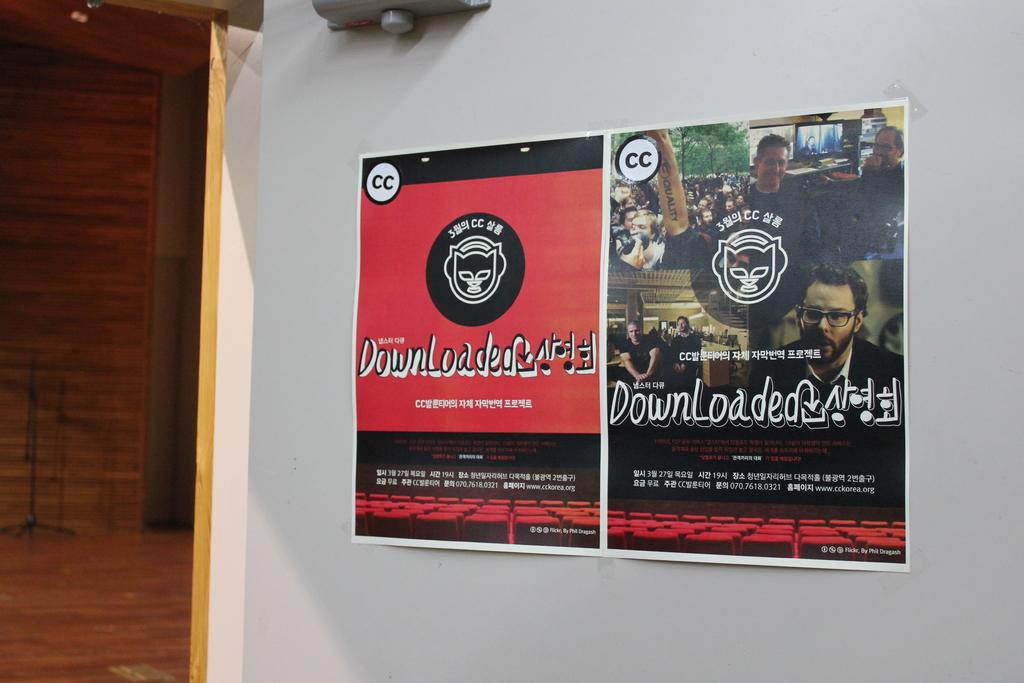<image>
Relay a brief, clear account of the picture shown. Two separate advertisement signs for Downloaded, one is red, the other has people in it 